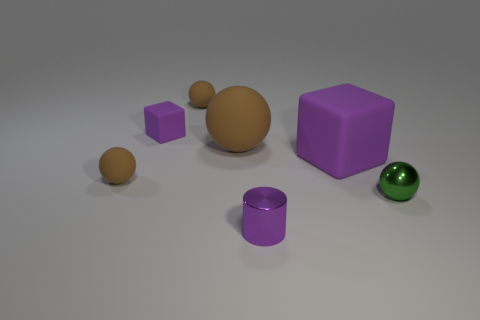Subtract all cyan cylinders. How many brown balls are left? 3 Add 1 tiny blocks. How many objects exist? 8 Subtract all spheres. How many objects are left? 3 Subtract 0 green cylinders. How many objects are left? 7 Subtract all gray metal objects. Subtract all big brown things. How many objects are left? 6 Add 7 brown balls. How many brown balls are left? 10 Add 6 small green objects. How many small green objects exist? 7 